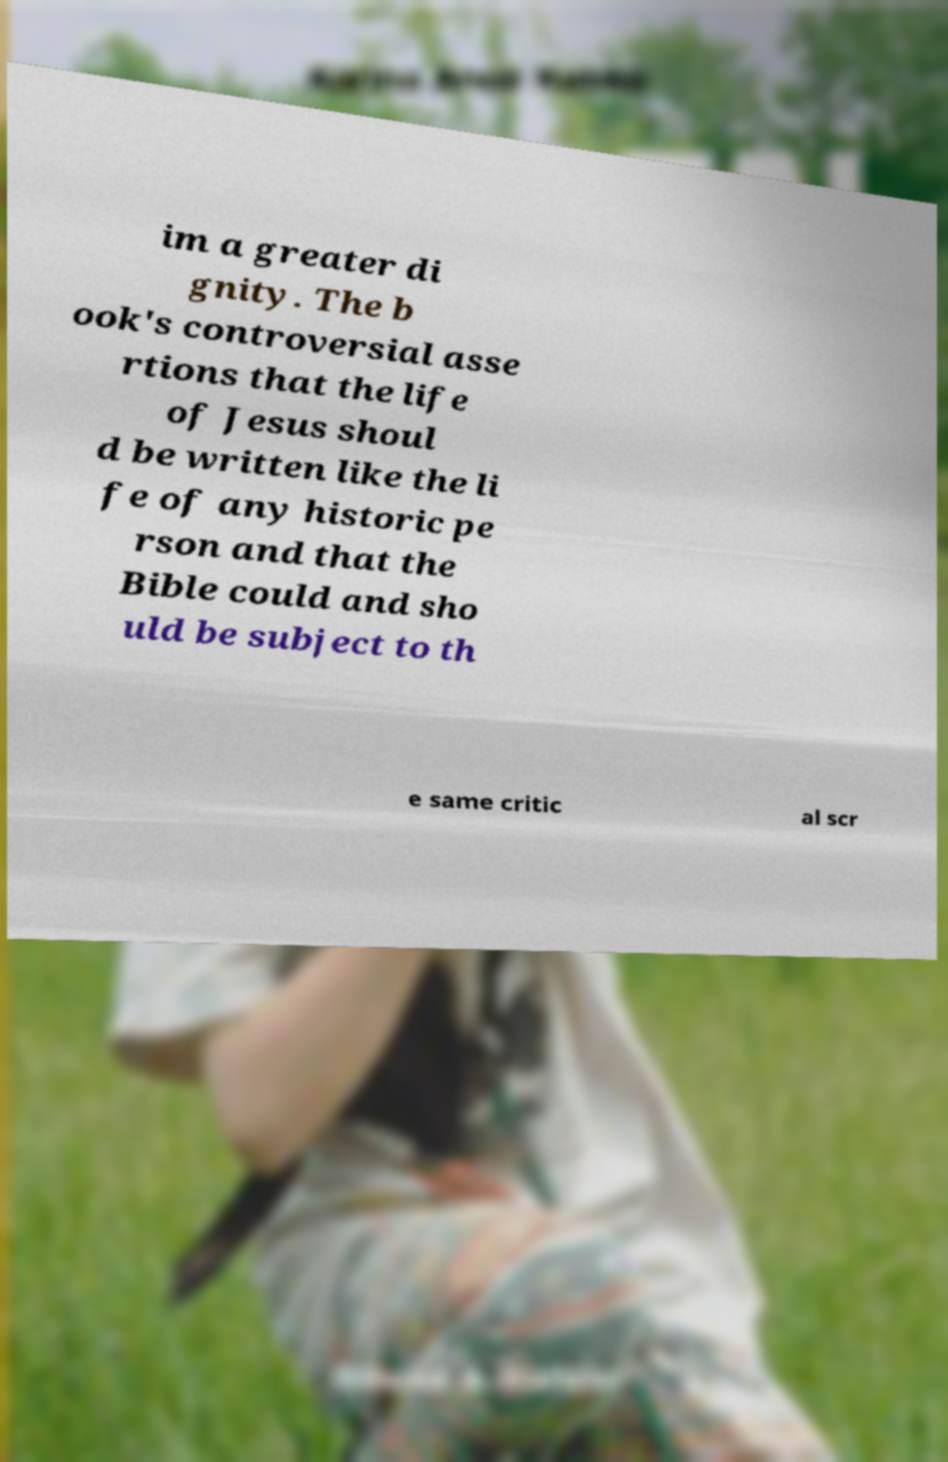Could you assist in decoding the text presented in this image and type it out clearly? im a greater di gnity. The b ook's controversial asse rtions that the life of Jesus shoul d be written like the li fe of any historic pe rson and that the Bible could and sho uld be subject to th e same critic al scr 